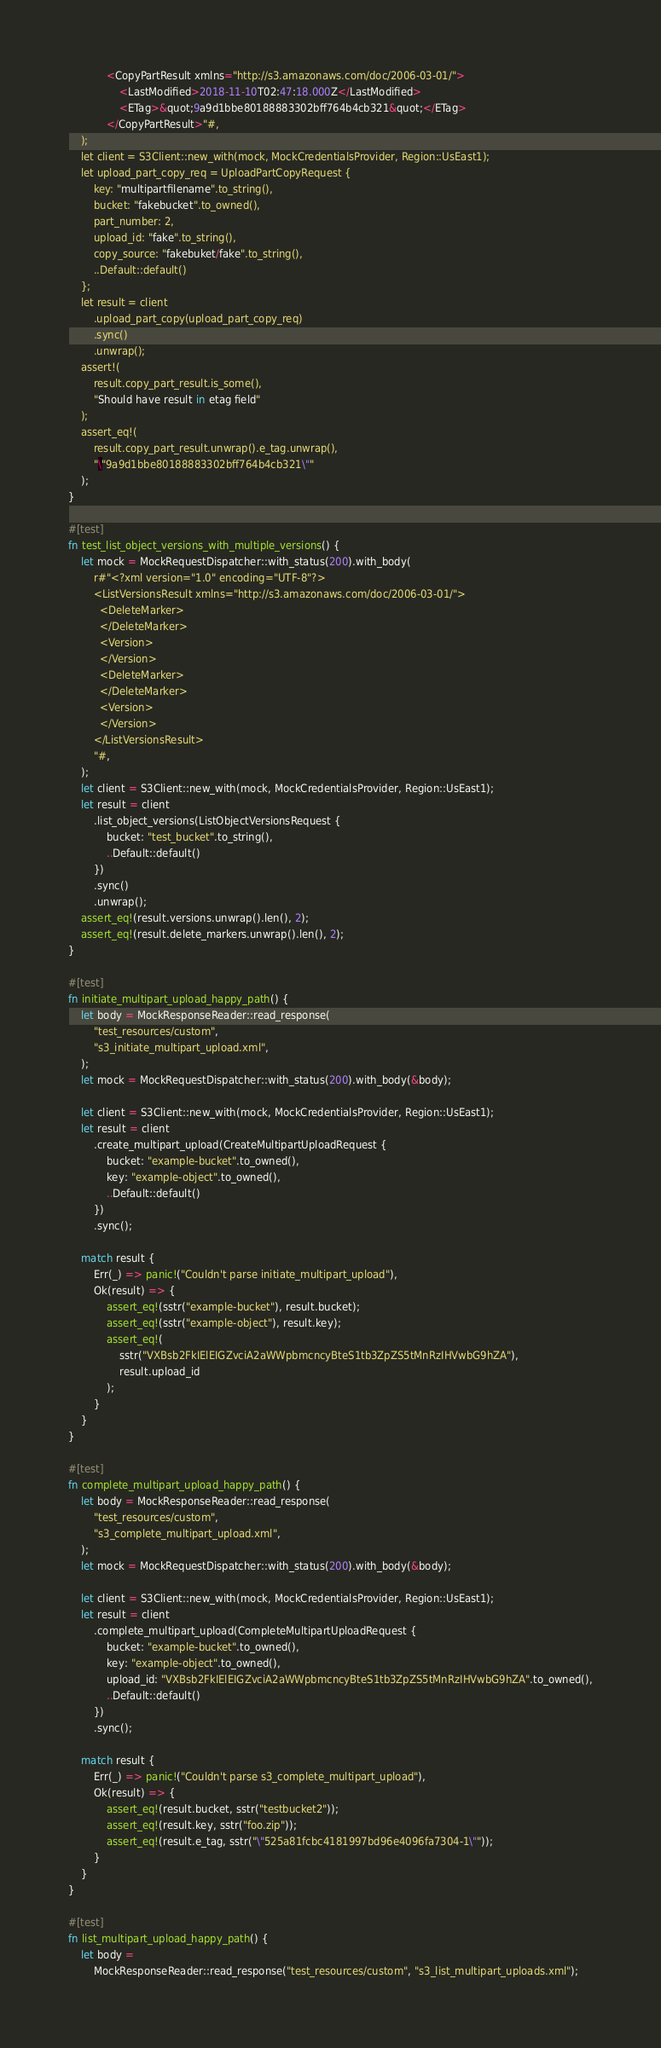<code> <loc_0><loc_0><loc_500><loc_500><_Rust_>            <CopyPartResult xmlns="http://s3.amazonaws.com/doc/2006-03-01/">
                <LastModified>2018-11-10T02:47:18.000Z</LastModified>
                <ETag>&quot;9a9d1bbe80188883302bff764b4cb321&quot;</ETag>
            </CopyPartResult>"#,
    );
    let client = S3Client::new_with(mock, MockCredentialsProvider, Region::UsEast1);
    let upload_part_copy_req = UploadPartCopyRequest {
        key: "multipartfilename".to_string(),
        bucket: "fakebucket".to_owned(),
        part_number: 2,
        upload_id: "fake".to_string(),
        copy_source: "fakebuket/fake".to_string(),
        ..Default::default()
    };
    let result = client
        .upload_part_copy(upload_part_copy_req)
        .sync()
        .unwrap();
    assert!(
        result.copy_part_result.is_some(),
        "Should have result in etag field"
    );
    assert_eq!(
        result.copy_part_result.unwrap().e_tag.unwrap(),
        "\"9a9d1bbe80188883302bff764b4cb321\""
    );
}

#[test]
fn test_list_object_versions_with_multiple_versions() {
    let mock = MockRequestDispatcher::with_status(200).with_body(
        r#"<?xml version="1.0" encoding="UTF-8"?>
        <ListVersionsResult xmlns="http://s3.amazonaws.com/doc/2006-03-01/">
          <DeleteMarker>
          </DeleteMarker>
          <Version>
          </Version>
          <DeleteMarker>
          </DeleteMarker>
          <Version>
          </Version>
        </ListVersionsResult>
        "#,
    );
    let client = S3Client::new_with(mock, MockCredentialsProvider, Region::UsEast1);
    let result = client
        .list_object_versions(ListObjectVersionsRequest {
            bucket: "test_bucket".to_string(),
            ..Default::default()
        })
        .sync()
        .unwrap();
    assert_eq!(result.versions.unwrap().len(), 2);
    assert_eq!(result.delete_markers.unwrap().len(), 2);
}

#[test]
fn initiate_multipart_upload_happy_path() {
    let body = MockResponseReader::read_response(
        "test_resources/custom",
        "s3_initiate_multipart_upload.xml",
    );
    let mock = MockRequestDispatcher::with_status(200).with_body(&body);

    let client = S3Client::new_with(mock, MockCredentialsProvider, Region::UsEast1);
    let result = client
        .create_multipart_upload(CreateMultipartUploadRequest {
            bucket: "example-bucket".to_owned(),
            key: "example-object".to_owned(),
            ..Default::default()
        })
        .sync();

    match result {
        Err(_) => panic!("Couldn't parse initiate_multipart_upload"),
        Ok(result) => {
            assert_eq!(sstr("example-bucket"), result.bucket);
            assert_eq!(sstr("example-object"), result.key);
            assert_eq!(
                sstr("VXBsb2FkIElEIGZvciA2aWWpbmcncyBteS1tb3ZpZS5tMnRzIHVwbG9hZA"),
                result.upload_id
            );
        }
    }
}

#[test]
fn complete_multipart_upload_happy_path() {
    let body = MockResponseReader::read_response(
        "test_resources/custom",
        "s3_complete_multipart_upload.xml",
    );
    let mock = MockRequestDispatcher::with_status(200).with_body(&body);

    let client = S3Client::new_with(mock, MockCredentialsProvider, Region::UsEast1);
    let result = client
        .complete_multipart_upload(CompleteMultipartUploadRequest {
            bucket: "example-bucket".to_owned(),
            key: "example-object".to_owned(),
            upload_id: "VXBsb2FkIElEIGZvciA2aWWpbmcncyBteS1tb3ZpZS5tMnRzIHVwbG9hZA".to_owned(),
            ..Default::default()
        })
        .sync();

    match result {
        Err(_) => panic!("Couldn't parse s3_complete_multipart_upload"),
        Ok(result) => {
            assert_eq!(result.bucket, sstr("testbucket2"));
            assert_eq!(result.key, sstr("foo.zip"));
            assert_eq!(result.e_tag, sstr("\"525a81fcbc4181997bd96e4096fa7304-1\""));
        }
    }
}

#[test]
fn list_multipart_upload_happy_path() {
    let body =
        MockResponseReader::read_response("test_resources/custom", "s3_list_multipart_uploads.xml");</code> 